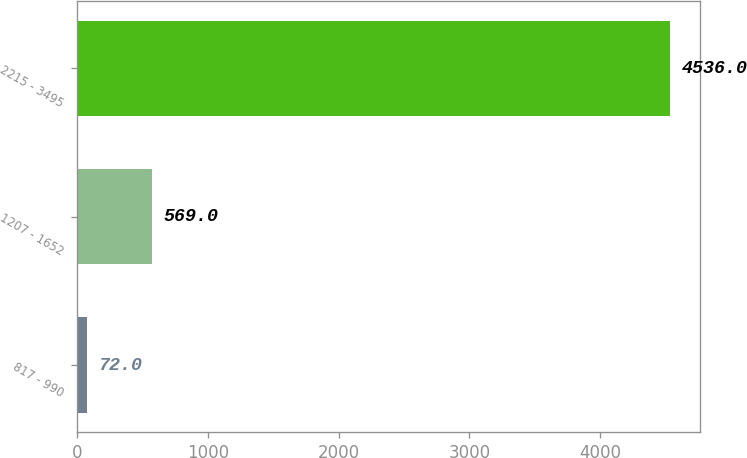Convert chart. <chart><loc_0><loc_0><loc_500><loc_500><bar_chart><fcel>817 - 990<fcel>1207 - 1652<fcel>2215 - 3495<nl><fcel>72<fcel>569<fcel>4536<nl></chart> 